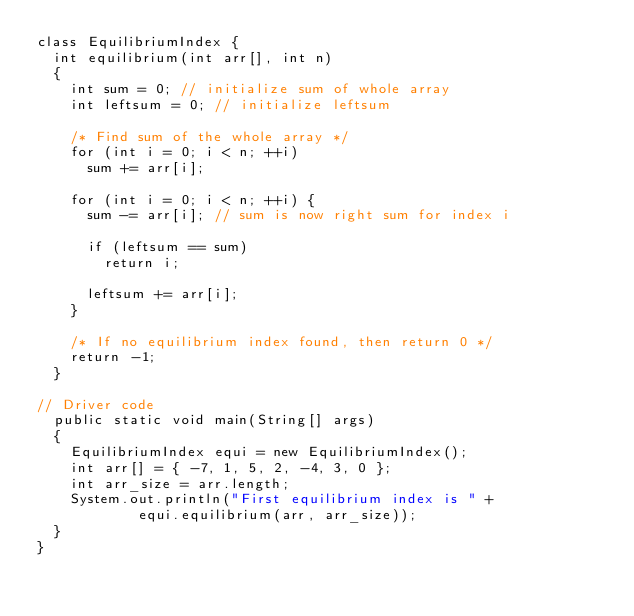Convert code to text. <code><loc_0><loc_0><loc_500><loc_500><_Java_>class EquilibriumIndex { 
	int equilibrium(int arr[], int n) 
	{ 
		int sum = 0; // initialize sum of whole array 
		int leftsum = 0; // initialize leftsum 

		/* Find sum of the whole array */
		for (int i = 0; i < n; ++i) 
			sum += arr[i]; 

		for (int i = 0; i < n; ++i) { 
			sum -= arr[i]; // sum is now right sum for index i 

			if (leftsum == sum) 
				return i; 

			leftsum += arr[i]; 
		} 

		/* If no equilibrium index found, then return 0 */
		return -1; 
	} 

// Driver code 
	public static void main(String[] args) 
	{ 
		EquilibriumIndex equi = new EquilibriumIndex(); 
		int arr[] = { -7, 1, 5, 2, -4, 3, 0 }; 
		int arr_size = arr.length; 
		System.out.println("First equilibrium index is " + 
						equi.equilibrium(arr, arr_size)); 
	} 
} 

</code> 